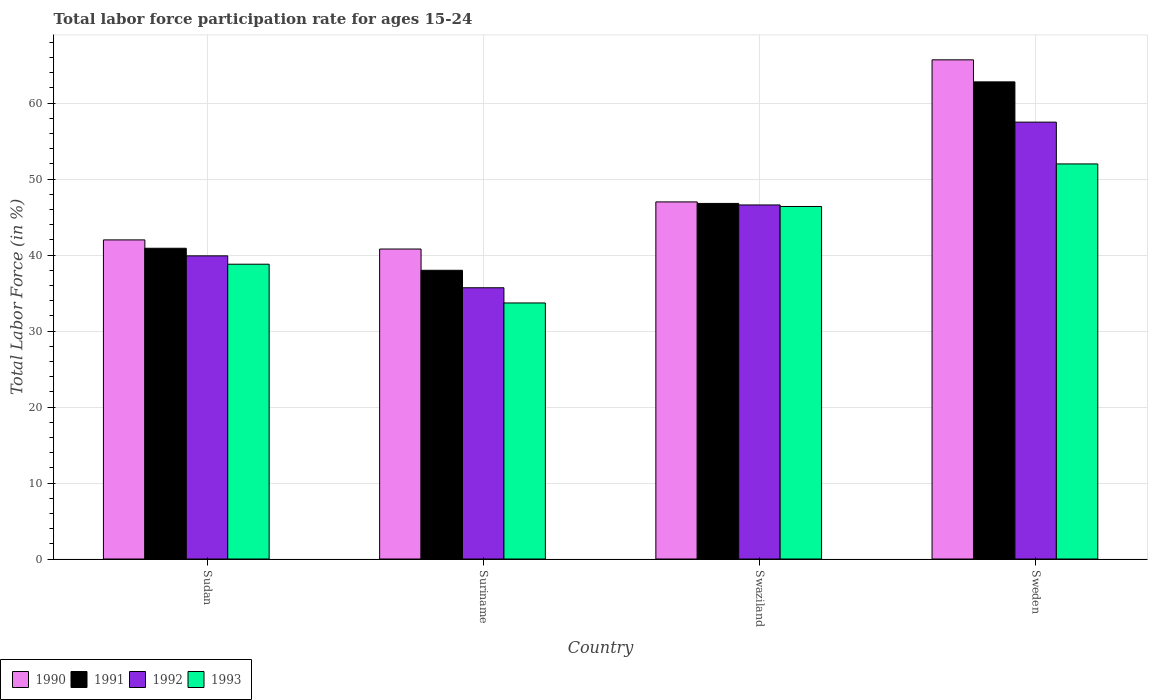How many different coloured bars are there?
Provide a short and direct response. 4. Are the number of bars per tick equal to the number of legend labels?
Offer a very short reply. Yes. How many bars are there on the 2nd tick from the left?
Offer a very short reply. 4. What is the labor force participation rate in 1992 in Sweden?
Ensure brevity in your answer.  57.5. Across all countries, what is the maximum labor force participation rate in 1992?
Provide a short and direct response. 57.5. Across all countries, what is the minimum labor force participation rate in 1993?
Provide a succinct answer. 33.7. In which country was the labor force participation rate in 1992 minimum?
Make the answer very short. Suriname. What is the total labor force participation rate in 1993 in the graph?
Your answer should be compact. 170.9. What is the difference between the labor force participation rate in 1992 in Sudan and that in Swaziland?
Your response must be concise. -6.7. What is the difference between the labor force participation rate in 1990 in Sweden and the labor force participation rate in 1993 in Suriname?
Your answer should be very brief. 32. What is the average labor force participation rate in 1993 per country?
Provide a succinct answer. 42.73. What is the difference between the labor force participation rate of/in 1992 and labor force participation rate of/in 1990 in Sudan?
Offer a very short reply. -2.1. In how many countries, is the labor force participation rate in 1992 greater than 62 %?
Make the answer very short. 0. What is the ratio of the labor force participation rate in 1992 in Swaziland to that in Sweden?
Give a very brief answer. 0.81. Is the difference between the labor force participation rate in 1992 in Sudan and Swaziland greater than the difference between the labor force participation rate in 1990 in Sudan and Swaziland?
Provide a succinct answer. No. What is the difference between the highest and the second highest labor force participation rate in 1993?
Offer a very short reply. -13.2. What is the difference between the highest and the lowest labor force participation rate in 1993?
Offer a very short reply. 18.3. In how many countries, is the labor force participation rate in 1990 greater than the average labor force participation rate in 1990 taken over all countries?
Provide a short and direct response. 1. What does the 4th bar from the right in Swaziland represents?
Provide a short and direct response. 1990. Are all the bars in the graph horizontal?
Your answer should be compact. No. How many countries are there in the graph?
Your answer should be very brief. 4. What is the difference between two consecutive major ticks on the Y-axis?
Make the answer very short. 10. Does the graph contain any zero values?
Keep it short and to the point. No. Does the graph contain grids?
Offer a terse response. Yes. Where does the legend appear in the graph?
Offer a very short reply. Bottom left. What is the title of the graph?
Ensure brevity in your answer.  Total labor force participation rate for ages 15-24. What is the label or title of the X-axis?
Your answer should be compact. Country. What is the label or title of the Y-axis?
Provide a succinct answer. Total Labor Force (in %). What is the Total Labor Force (in %) of 1990 in Sudan?
Keep it short and to the point. 42. What is the Total Labor Force (in %) of 1991 in Sudan?
Offer a very short reply. 40.9. What is the Total Labor Force (in %) of 1992 in Sudan?
Your answer should be very brief. 39.9. What is the Total Labor Force (in %) of 1993 in Sudan?
Give a very brief answer. 38.8. What is the Total Labor Force (in %) in 1990 in Suriname?
Your answer should be compact. 40.8. What is the Total Labor Force (in %) in 1991 in Suriname?
Provide a succinct answer. 38. What is the Total Labor Force (in %) in 1992 in Suriname?
Keep it short and to the point. 35.7. What is the Total Labor Force (in %) in 1993 in Suriname?
Provide a short and direct response. 33.7. What is the Total Labor Force (in %) in 1991 in Swaziland?
Offer a terse response. 46.8. What is the Total Labor Force (in %) of 1992 in Swaziland?
Provide a succinct answer. 46.6. What is the Total Labor Force (in %) in 1993 in Swaziland?
Your answer should be very brief. 46.4. What is the Total Labor Force (in %) in 1990 in Sweden?
Offer a very short reply. 65.7. What is the Total Labor Force (in %) in 1991 in Sweden?
Make the answer very short. 62.8. What is the Total Labor Force (in %) of 1992 in Sweden?
Offer a terse response. 57.5. What is the Total Labor Force (in %) of 1993 in Sweden?
Your answer should be compact. 52. Across all countries, what is the maximum Total Labor Force (in %) of 1990?
Your answer should be very brief. 65.7. Across all countries, what is the maximum Total Labor Force (in %) of 1991?
Give a very brief answer. 62.8. Across all countries, what is the maximum Total Labor Force (in %) of 1992?
Provide a succinct answer. 57.5. Across all countries, what is the minimum Total Labor Force (in %) of 1990?
Offer a terse response. 40.8. Across all countries, what is the minimum Total Labor Force (in %) in 1992?
Ensure brevity in your answer.  35.7. Across all countries, what is the minimum Total Labor Force (in %) of 1993?
Ensure brevity in your answer.  33.7. What is the total Total Labor Force (in %) of 1990 in the graph?
Give a very brief answer. 195.5. What is the total Total Labor Force (in %) of 1991 in the graph?
Your response must be concise. 188.5. What is the total Total Labor Force (in %) of 1992 in the graph?
Offer a terse response. 179.7. What is the total Total Labor Force (in %) of 1993 in the graph?
Give a very brief answer. 170.9. What is the difference between the Total Labor Force (in %) of 1991 in Sudan and that in Suriname?
Ensure brevity in your answer.  2.9. What is the difference between the Total Labor Force (in %) of 1990 in Sudan and that in Sweden?
Provide a short and direct response. -23.7. What is the difference between the Total Labor Force (in %) of 1991 in Sudan and that in Sweden?
Your response must be concise. -21.9. What is the difference between the Total Labor Force (in %) of 1992 in Sudan and that in Sweden?
Give a very brief answer. -17.6. What is the difference between the Total Labor Force (in %) in 1991 in Suriname and that in Swaziland?
Ensure brevity in your answer.  -8.8. What is the difference between the Total Labor Force (in %) in 1993 in Suriname and that in Swaziland?
Your answer should be very brief. -12.7. What is the difference between the Total Labor Force (in %) of 1990 in Suriname and that in Sweden?
Provide a succinct answer. -24.9. What is the difference between the Total Labor Force (in %) of 1991 in Suriname and that in Sweden?
Your answer should be very brief. -24.8. What is the difference between the Total Labor Force (in %) of 1992 in Suriname and that in Sweden?
Offer a very short reply. -21.8. What is the difference between the Total Labor Force (in %) in 1993 in Suriname and that in Sweden?
Provide a succinct answer. -18.3. What is the difference between the Total Labor Force (in %) in 1990 in Swaziland and that in Sweden?
Your answer should be very brief. -18.7. What is the difference between the Total Labor Force (in %) of 1991 in Swaziland and that in Sweden?
Make the answer very short. -16. What is the difference between the Total Labor Force (in %) in 1992 in Swaziland and that in Sweden?
Provide a short and direct response. -10.9. What is the difference between the Total Labor Force (in %) in 1993 in Swaziland and that in Sweden?
Provide a short and direct response. -5.6. What is the difference between the Total Labor Force (in %) in 1990 in Sudan and the Total Labor Force (in %) in 1992 in Suriname?
Your answer should be very brief. 6.3. What is the difference between the Total Labor Force (in %) of 1991 in Sudan and the Total Labor Force (in %) of 1992 in Suriname?
Give a very brief answer. 5.2. What is the difference between the Total Labor Force (in %) in 1991 in Sudan and the Total Labor Force (in %) in 1993 in Suriname?
Provide a short and direct response. 7.2. What is the difference between the Total Labor Force (in %) in 1990 in Sudan and the Total Labor Force (in %) in 1991 in Swaziland?
Your response must be concise. -4.8. What is the difference between the Total Labor Force (in %) in 1991 in Sudan and the Total Labor Force (in %) in 1993 in Swaziland?
Make the answer very short. -5.5. What is the difference between the Total Labor Force (in %) in 1992 in Sudan and the Total Labor Force (in %) in 1993 in Swaziland?
Provide a short and direct response. -6.5. What is the difference between the Total Labor Force (in %) in 1990 in Sudan and the Total Labor Force (in %) in 1991 in Sweden?
Ensure brevity in your answer.  -20.8. What is the difference between the Total Labor Force (in %) of 1990 in Sudan and the Total Labor Force (in %) of 1992 in Sweden?
Offer a very short reply. -15.5. What is the difference between the Total Labor Force (in %) in 1990 in Sudan and the Total Labor Force (in %) in 1993 in Sweden?
Your answer should be compact. -10. What is the difference between the Total Labor Force (in %) in 1991 in Sudan and the Total Labor Force (in %) in 1992 in Sweden?
Your answer should be very brief. -16.6. What is the difference between the Total Labor Force (in %) of 1991 in Sudan and the Total Labor Force (in %) of 1993 in Sweden?
Give a very brief answer. -11.1. What is the difference between the Total Labor Force (in %) of 1992 in Sudan and the Total Labor Force (in %) of 1993 in Sweden?
Your response must be concise. -12.1. What is the difference between the Total Labor Force (in %) in 1990 in Suriname and the Total Labor Force (in %) in 1992 in Swaziland?
Provide a short and direct response. -5.8. What is the difference between the Total Labor Force (in %) of 1991 in Suriname and the Total Labor Force (in %) of 1992 in Swaziland?
Provide a short and direct response. -8.6. What is the difference between the Total Labor Force (in %) of 1991 in Suriname and the Total Labor Force (in %) of 1993 in Swaziland?
Provide a succinct answer. -8.4. What is the difference between the Total Labor Force (in %) of 1992 in Suriname and the Total Labor Force (in %) of 1993 in Swaziland?
Ensure brevity in your answer.  -10.7. What is the difference between the Total Labor Force (in %) in 1990 in Suriname and the Total Labor Force (in %) in 1992 in Sweden?
Offer a terse response. -16.7. What is the difference between the Total Labor Force (in %) of 1990 in Suriname and the Total Labor Force (in %) of 1993 in Sweden?
Provide a succinct answer. -11.2. What is the difference between the Total Labor Force (in %) of 1991 in Suriname and the Total Labor Force (in %) of 1992 in Sweden?
Offer a very short reply. -19.5. What is the difference between the Total Labor Force (in %) of 1991 in Suriname and the Total Labor Force (in %) of 1993 in Sweden?
Offer a very short reply. -14. What is the difference between the Total Labor Force (in %) of 1992 in Suriname and the Total Labor Force (in %) of 1993 in Sweden?
Provide a short and direct response. -16.3. What is the difference between the Total Labor Force (in %) of 1990 in Swaziland and the Total Labor Force (in %) of 1991 in Sweden?
Give a very brief answer. -15.8. What is the difference between the Total Labor Force (in %) of 1990 in Swaziland and the Total Labor Force (in %) of 1992 in Sweden?
Ensure brevity in your answer.  -10.5. What is the difference between the Total Labor Force (in %) in 1990 in Swaziland and the Total Labor Force (in %) in 1993 in Sweden?
Offer a terse response. -5. What is the average Total Labor Force (in %) of 1990 per country?
Give a very brief answer. 48.88. What is the average Total Labor Force (in %) in 1991 per country?
Give a very brief answer. 47.12. What is the average Total Labor Force (in %) of 1992 per country?
Ensure brevity in your answer.  44.92. What is the average Total Labor Force (in %) of 1993 per country?
Your answer should be compact. 42.73. What is the difference between the Total Labor Force (in %) of 1990 and Total Labor Force (in %) of 1991 in Sudan?
Ensure brevity in your answer.  1.1. What is the difference between the Total Labor Force (in %) of 1990 and Total Labor Force (in %) of 1993 in Sudan?
Make the answer very short. 3.2. What is the difference between the Total Labor Force (in %) of 1992 and Total Labor Force (in %) of 1993 in Sudan?
Your response must be concise. 1.1. What is the difference between the Total Labor Force (in %) of 1990 and Total Labor Force (in %) of 1993 in Suriname?
Your response must be concise. 7.1. What is the difference between the Total Labor Force (in %) of 1991 and Total Labor Force (in %) of 1992 in Suriname?
Provide a short and direct response. 2.3. What is the difference between the Total Labor Force (in %) of 1991 and Total Labor Force (in %) of 1993 in Suriname?
Keep it short and to the point. 4.3. What is the difference between the Total Labor Force (in %) in 1992 and Total Labor Force (in %) in 1993 in Suriname?
Provide a short and direct response. 2. What is the difference between the Total Labor Force (in %) of 1991 and Total Labor Force (in %) of 1992 in Swaziland?
Provide a short and direct response. 0.2. What is the difference between the Total Labor Force (in %) in 1991 and Total Labor Force (in %) in 1993 in Swaziland?
Your answer should be very brief. 0.4. What is the difference between the Total Labor Force (in %) in 1992 and Total Labor Force (in %) in 1993 in Swaziland?
Provide a short and direct response. 0.2. What is the difference between the Total Labor Force (in %) in 1991 and Total Labor Force (in %) in 1993 in Sweden?
Give a very brief answer. 10.8. What is the difference between the Total Labor Force (in %) of 1992 and Total Labor Force (in %) of 1993 in Sweden?
Make the answer very short. 5.5. What is the ratio of the Total Labor Force (in %) in 1990 in Sudan to that in Suriname?
Provide a short and direct response. 1.03. What is the ratio of the Total Labor Force (in %) of 1991 in Sudan to that in Suriname?
Provide a succinct answer. 1.08. What is the ratio of the Total Labor Force (in %) in 1992 in Sudan to that in Suriname?
Your answer should be very brief. 1.12. What is the ratio of the Total Labor Force (in %) of 1993 in Sudan to that in Suriname?
Make the answer very short. 1.15. What is the ratio of the Total Labor Force (in %) of 1990 in Sudan to that in Swaziland?
Keep it short and to the point. 0.89. What is the ratio of the Total Labor Force (in %) in 1991 in Sudan to that in Swaziland?
Your response must be concise. 0.87. What is the ratio of the Total Labor Force (in %) in 1992 in Sudan to that in Swaziland?
Keep it short and to the point. 0.86. What is the ratio of the Total Labor Force (in %) in 1993 in Sudan to that in Swaziland?
Your response must be concise. 0.84. What is the ratio of the Total Labor Force (in %) of 1990 in Sudan to that in Sweden?
Provide a short and direct response. 0.64. What is the ratio of the Total Labor Force (in %) in 1991 in Sudan to that in Sweden?
Offer a terse response. 0.65. What is the ratio of the Total Labor Force (in %) in 1992 in Sudan to that in Sweden?
Keep it short and to the point. 0.69. What is the ratio of the Total Labor Force (in %) of 1993 in Sudan to that in Sweden?
Provide a succinct answer. 0.75. What is the ratio of the Total Labor Force (in %) in 1990 in Suriname to that in Swaziland?
Offer a very short reply. 0.87. What is the ratio of the Total Labor Force (in %) of 1991 in Suriname to that in Swaziland?
Your answer should be compact. 0.81. What is the ratio of the Total Labor Force (in %) in 1992 in Suriname to that in Swaziland?
Your response must be concise. 0.77. What is the ratio of the Total Labor Force (in %) in 1993 in Suriname to that in Swaziland?
Your answer should be compact. 0.73. What is the ratio of the Total Labor Force (in %) of 1990 in Suriname to that in Sweden?
Make the answer very short. 0.62. What is the ratio of the Total Labor Force (in %) of 1991 in Suriname to that in Sweden?
Your answer should be compact. 0.61. What is the ratio of the Total Labor Force (in %) of 1992 in Suriname to that in Sweden?
Make the answer very short. 0.62. What is the ratio of the Total Labor Force (in %) in 1993 in Suriname to that in Sweden?
Provide a short and direct response. 0.65. What is the ratio of the Total Labor Force (in %) of 1990 in Swaziland to that in Sweden?
Your response must be concise. 0.72. What is the ratio of the Total Labor Force (in %) in 1991 in Swaziland to that in Sweden?
Keep it short and to the point. 0.75. What is the ratio of the Total Labor Force (in %) in 1992 in Swaziland to that in Sweden?
Make the answer very short. 0.81. What is the ratio of the Total Labor Force (in %) in 1993 in Swaziland to that in Sweden?
Your answer should be compact. 0.89. What is the difference between the highest and the lowest Total Labor Force (in %) in 1990?
Give a very brief answer. 24.9. What is the difference between the highest and the lowest Total Labor Force (in %) of 1991?
Offer a terse response. 24.8. What is the difference between the highest and the lowest Total Labor Force (in %) of 1992?
Give a very brief answer. 21.8. 